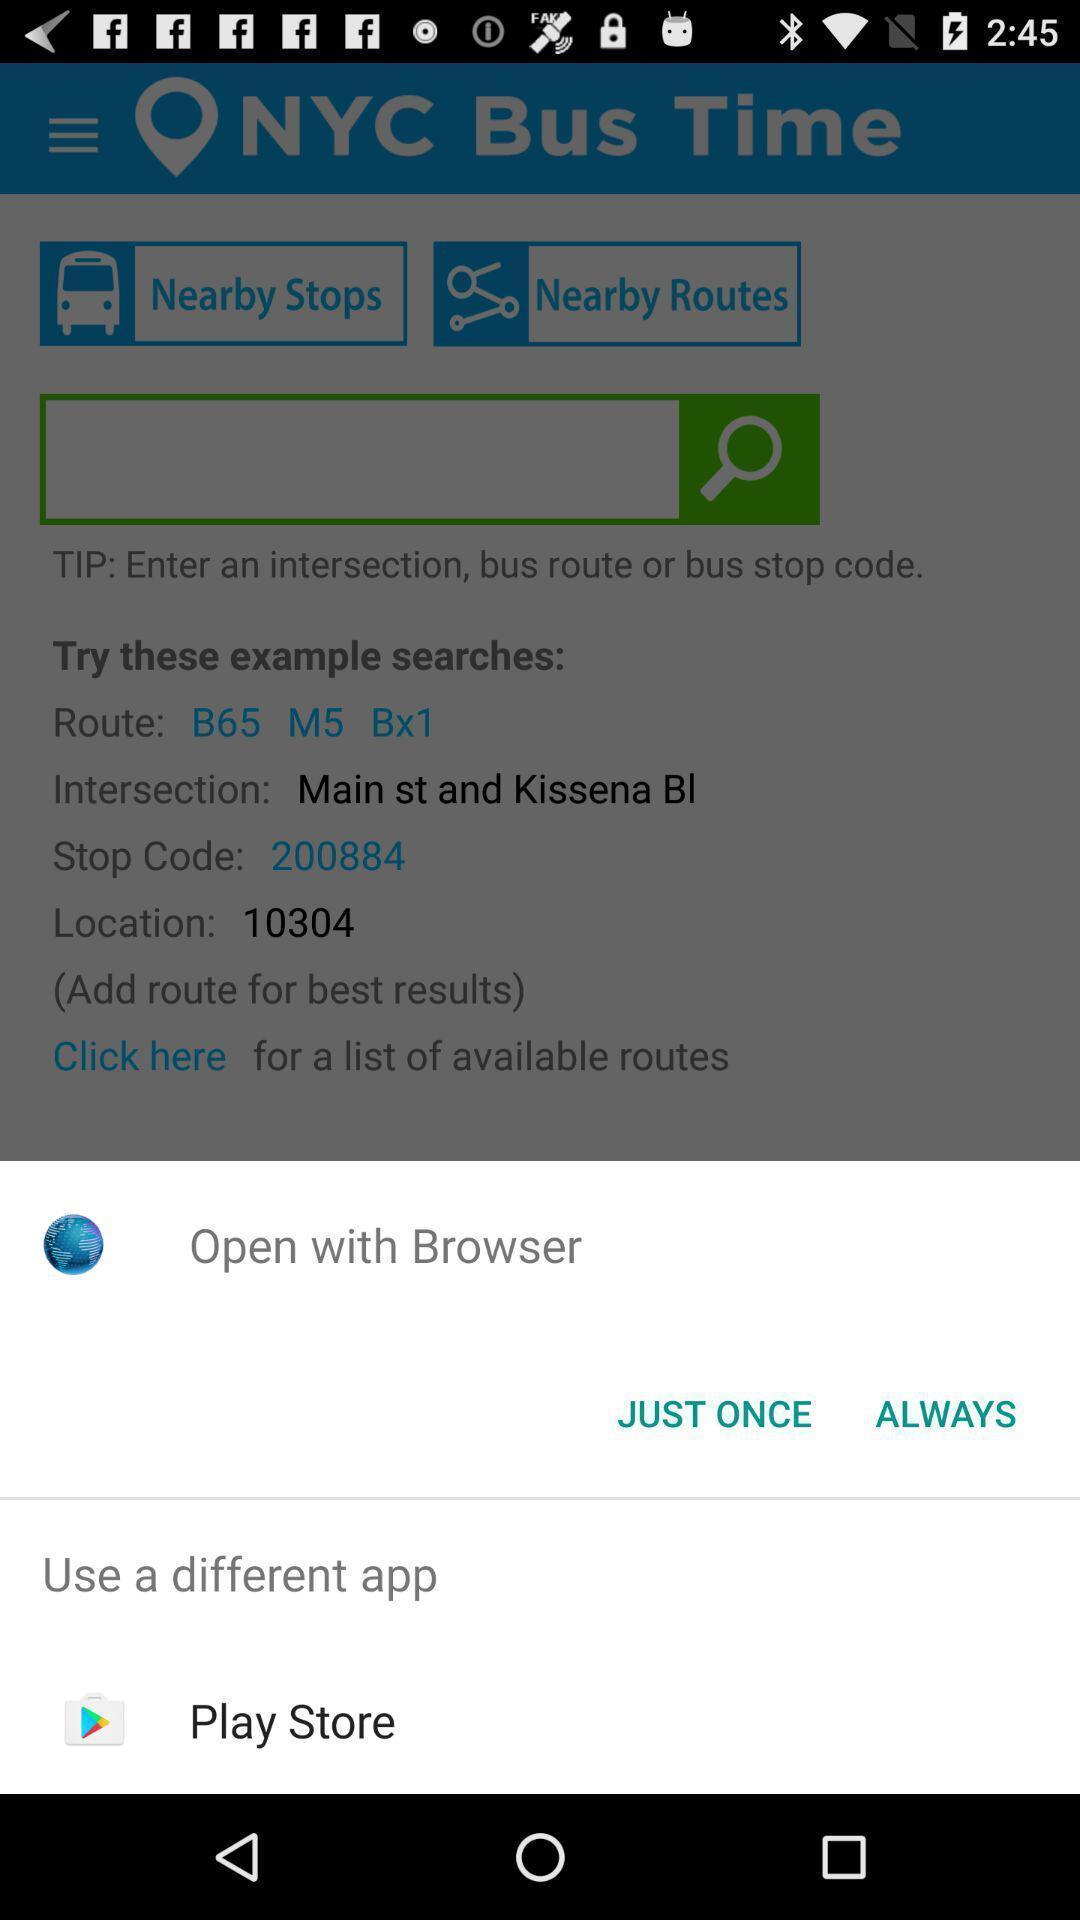Describe the key features of this screenshot. Pop up shows to open with other app. 